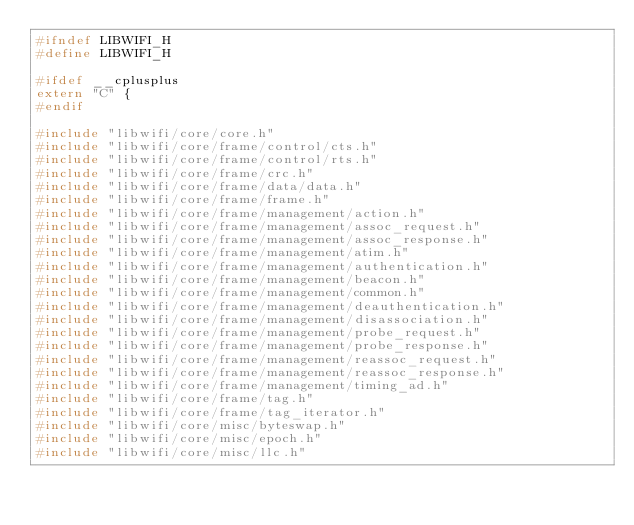<code> <loc_0><loc_0><loc_500><loc_500><_C_>#ifndef LIBWIFI_H
#define LIBWIFI_H

#ifdef __cplusplus
extern "C" {
#endif

#include "libwifi/core/core.h"
#include "libwifi/core/frame/control/cts.h"
#include "libwifi/core/frame/control/rts.h"
#include "libwifi/core/frame/crc.h"
#include "libwifi/core/frame/data/data.h"
#include "libwifi/core/frame/frame.h"
#include "libwifi/core/frame/management/action.h"
#include "libwifi/core/frame/management/assoc_request.h"
#include "libwifi/core/frame/management/assoc_response.h"
#include "libwifi/core/frame/management/atim.h"
#include "libwifi/core/frame/management/authentication.h"
#include "libwifi/core/frame/management/beacon.h"
#include "libwifi/core/frame/management/common.h"
#include "libwifi/core/frame/management/deauthentication.h"
#include "libwifi/core/frame/management/disassociation.h"
#include "libwifi/core/frame/management/probe_request.h"
#include "libwifi/core/frame/management/probe_response.h"
#include "libwifi/core/frame/management/reassoc_request.h"
#include "libwifi/core/frame/management/reassoc_response.h"
#include "libwifi/core/frame/management/timing_ad.h"
#include "libwifi/core/frame/tag.h"
#include "libwifi/core/frame/tag_iterator.h"
#include "libwifi/core/misc/byteswap.h"
#include "libwifi/core/misc/epoch.h"
#include "libwifi/core/misc/llc.h"</code> 